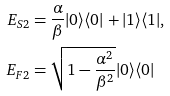Convert formula to latex. <formula><loc_0><loc_0><loc_500><loc_500>E _ { S 2 } & = \frac { \alpha } { \beta } | 0 \rangle \langle 0 | + | 1 \rangle \langle 1 | , \\ E _ { F 2 } & = \sqrt { 1 - \frac { \alpha ^ { 2 } } { \beta ^ { 2 } } } | 0 \rangle \langle 0 |</formula> 